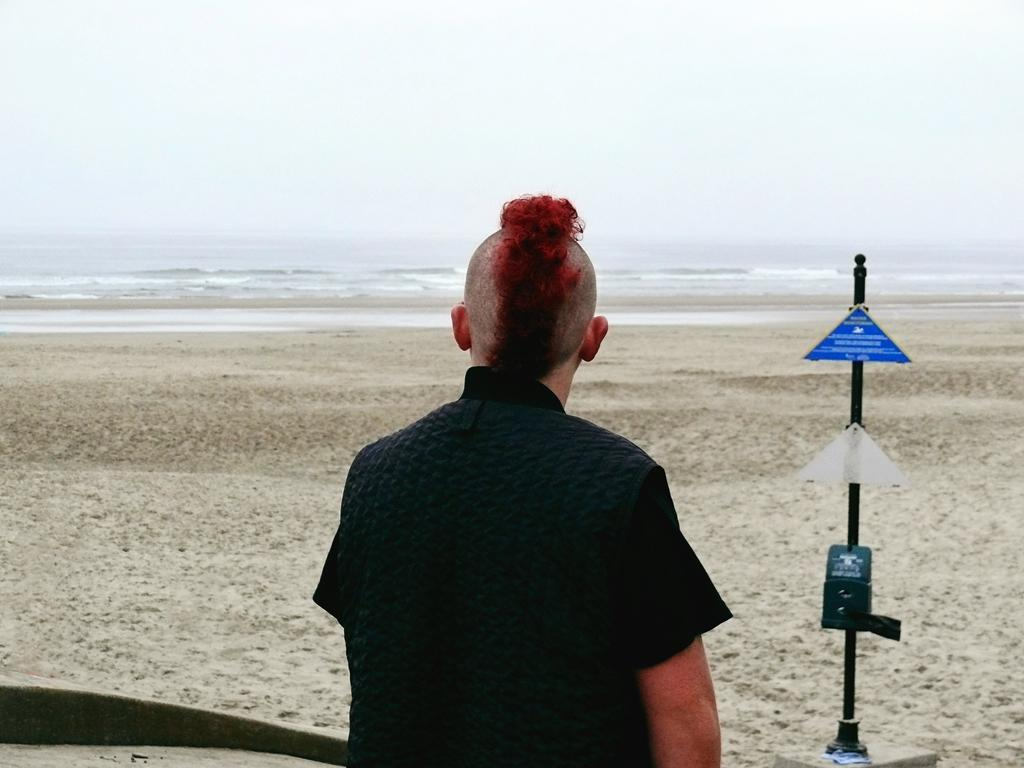What is the appearance of the person in the image? There is a person with red hair in the image. What is the person doing in the image? The person is sitting on the sand and looking at the sea. What can be seen on the right side of the image? There are sign boards on the right side of the image. What type of dinner is being served in the image? There is no dinner present in the image; it features a person sitting on the sand and looking at the sea. How many cents are visible in the image? There is no mention of any currency or cents in the image. 